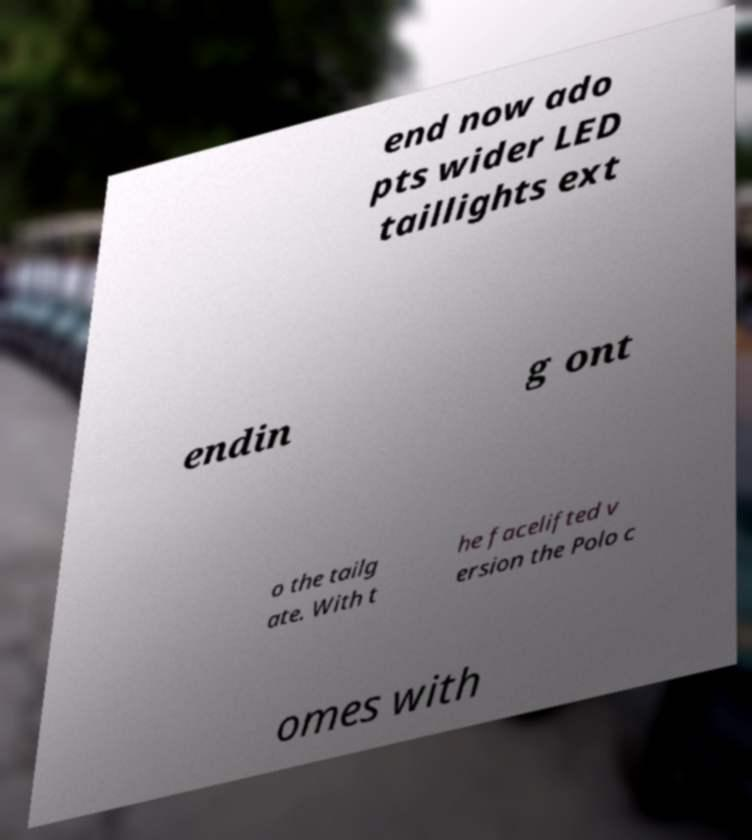There's text embedded in this image that I need extracted. Can you transcribe it verbatim? end now ado pts wider LED taillights ext endin g ont o the tailg ate. With t he facelifted v ersion the Polo c omes with 